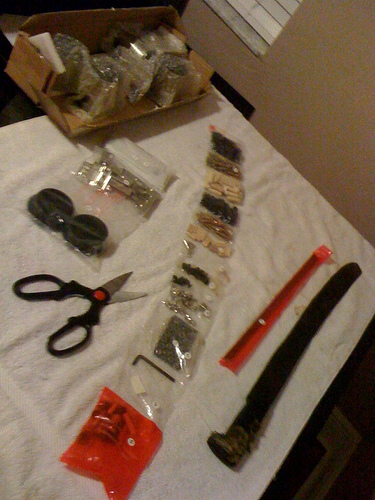<image>What type of knife is in this picture? There is no knife in the picture. However, it might be a machete. What is in the red envelopes? It is ambiguous what's in the red envelopes. It could be nothing, screws, seasoning, beads, parts, sewing notions or it could be unknown. What type of knife is in this picture? I am not sure what type of knife is in this picture. It can be seen as 'machete', 'putty', 'large', or 'saw'. What is in the red envelopes? I am not sure what is in the red envelopes. It can be nothing, screws, seasoning, beads, parts, sewing notions, or something else. 